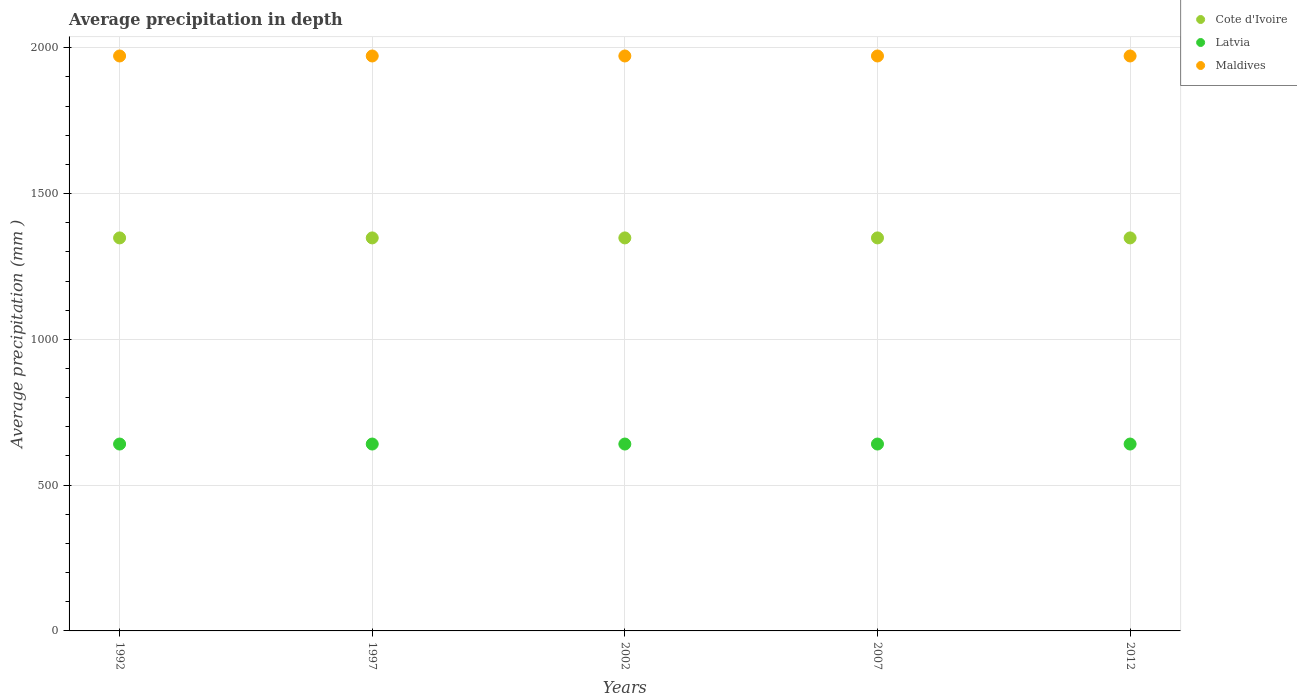How many different coloured dotlines are there?
Your answer should be very brief. 3. What is the average precipitation in Latvia in 2012?
Offer a terse response. 641. Across all years, what is the maximum average precipitation in Cote d'Ivoire?
Make the answer very short. 1348. In which year was the average precipitation in Maldives maximum?
Offer a very short reply. 1992. In which year was the average precipitation in Maldives minimum?
Keep it short and to the point. 1992. What is the total average precipitation in Maldives in the graph?
Provide a succinct answer. 9860. What is the difference between the average precipitation in Maldives in 1992 and that in 2007?
Ensure brevity in your answer.  0. What is the difference between the average precipitation in Latvia in 1997 and the average precipitation in Maldives in 2012?
Give a very brief answer. -1331. What is the average average precipitation in Maldives per year?
Give a very brief answer. 1972. In the year 2007, what is the difference between the average precipitation in Latvia and average precipitation in Maldives?
Offer a very short reply. -1331. Is the average precipitation in Latvia in 2007 less than that in 2012?
Offer a very short reply. No. Is the difference between the average precipitation in Latvia in 1997 and 2002 greater than the difference between the average precipitation in Maldives in 1997 and 2002?
Your answer should be very brief. No. What is the difference between the highest and the second highest average precipitation in Cote d'Ivoire?
Provide a short and direct response. 0. What is the difference between the highest and the lowest average precipitation in Cote d'Ivoire?
Provide a short and direct response. 0. Is it the case that in every year, the sum of the average precipitation in Latvia and average precipitation in Cote d'Ivoire  is greater than the average precipitation in Maldives?
Keep it short and to the point. Yes. How many years are there in the graph?
Your answer should be very brief. 5. Are the values on the major ticks of Y-axis written in scientific E-notation?
Your answer should be compact. No. Does the graph contain any zero values?
Offer a very short reply. No. Does the graph contain grids?
Your answer should be compact. Yes. How many legend labels are there?
Offer a very short reply. 3. How are the legend labels stacked?
Make the answer very short. Vertical. What is the title of the graph?
Ensure brevity in your answer.  Average precipitation in depth. What is the label or title of the X-axis?
Provide a succinct answer. Years. What is the label or title of the Y-axis?
Offer a very short reply. Average precipitation (mm ). What is the Average precipitation (mm ) in Cote d'Ivoire in 1992?
Provide a succinct answer. 1348. What is the Average precipitation (mm ) in Latvia in 1992?
Offer a terse response. 641. What is the Average precipitation (mm ) in Maldives in 1992?
Your answer should be compact. 1972. What is the Average precipitation (mm ) of Cote d'Ivoire in 1997?
Offer a very short reply. 1348. What is the Average precipitation (mm ) in Latvia in 1997?
Offer a terse response. 641. What is the Average precipitation (mm ) in Maldives in 1997?
Ensure brevity in your answer.  1972. What is the Average precipitation (mm ) of Cote d'Ivoire in 2002?
Ensure brevity in your answer.  1348. What is the Average precipitation (mm ) of Latvia in 2002?
Your answer should be very brief. 641. What is the Average precipitation (mm ) of Maldives in 2002?
Provide a succinct answer. 1972. What is the Average precipitation (mm ) in Cote d'Ivoire in 2007?
Offer a terse response. 1348. What is the Average precipitation (mm ) of Latvia in 2007?
Provide a succinct answer. 641. What is the Average precipitation (mm ) of Maldives in 2007?
Make the answer very short. 1972. What is the Average precipitation (mm ) in Cote d'Ivoire in 2012?
Your answer should be very brief. 1348. What is the Average precipitation (mm ) of Latvia in 2012?
Keep it short and to the point. 641. What is the Average precipitation (mm ) in Maldives in 2012?
Your answer should be very brief. 1972. Across all years, what is the maximum Average precipitation (mm ) in Cote d'Ivoire?
Your answer should be very brief. 1348. Across all years, what is the maximum Average precipitation (mm ) of Latvia?
Give a very brief answer. 641. Across all years, what is the maximum Average precipitation (mm ) of Maldives?
Ensure brevity in your answer.  1972. Across all years, what is the minimum Average precipitation (mm ) of Cote d'Ivoire?
Make the answer very short. 1348. Across all years, what is the minimum Average precipitation (mm ) of Latvia?
Your answer should be compact. 641. Across all years, what is the minimum Average precipitation (mm ) of Maldives?
Keep it short and to the point. 1972. What is the total Average precipitation (mm ) of Cote d'Ivoire in the graph?
Your answer should be very brief. 6740. What is the total Average precipitation (mm ) in Latvia in the graph?
Give a very brief answer. 3205. What is the total Average precipitation (mm ) in Maldives in the graph?
Make the answer very short. 9860. What is the difference between the Average precipitation (mm ) in Cote d'Ivoire in 1992 and that in 1997?
Your answer should be compact. 0. What is the difference between the Average precipitation (mm ) in Latvia in 1992 and that in 1997?
Your response must be concise. 0. What is the difference between the Average precipitation (mm ) in Cote d'Ivoire in 1992 and that in 2002?
Offer a very short reply. 0. What is the difference between the Average precipitation (mm ) in Latvia in 1992 and that in 2002?
Keep it short and to the point. 0. What is the difference between the Average precipitation (mm ) in Latvia in 1992 and that in 2007?
Make the answer very short. 0. What is the difference between the Average precipitation (mm ) of Cote d'Ivoire in 1997 and that in 2002?
Provide a succinct answer. 0. What is the difference between the Average precipitation (mm ) in Latvia in 1997 and that in 2002?
Provide a short and direct response. 0. What is the difference between the Average precipitation (mm ) in Maldives in 1997 and that in 2002?
Make the answer very short. 0. What is the difference between the Average precipitation (mm ) in Cote d'Ivoire in 1997 and that in 2007?
Give a very brief answer. 0. What is the difference between the Average precipitation (mm ) in Latvia in 1997 and that in 2012?
Give a very brief answer. 0. What is the difference between the Average precipitation (mm ) of Maldives in 2002 and that in 2007?
Your answer should be very brief. 0. What is the difference between the Average precipitation (mm ) of Maldives in 2002 and that in 2012?
Your response must be concise. 0. What is the difference between the Average precipitation (mm ) of Maldives in 2007 and that in 2012?
Make the answer very short. 0. What is the difference between the Average precipitation (mm ) in Cote d'Ivoire in 1992 and the Average precipitation (mm ) in Latvia in 1997?
Ensure brevity in your answer.  707. What is the difference between the Average precipitation (mm ) in Cote d'Ivoire in 1992 and the Average precipitation (mm ) in Maldives in 1997?
Your answer should be compact. -624. What is the difference between the Average precipitation (mm ) in Latvia in 1992 and the Average precipitation (mm ) in Maldives in 1997?
Keep it short and to the point. -1331. What is the difference between the Average precipitation (mm ) in Cote d'Ivoire in 1992 and the Average precipitation (mm ) in Latvia in 2002?
Your answer should be very brief. 707. What is the difference between the Average precipitation (mm ) in Cote d'Ivoire in 1992 and the Average precipitation (mm ) in Maldives in 2002?
Your answer should be compact. -624. What is the difference between the Average precipitation (mm ) in Latvia in 1992 and the Average precipitation (mm ) in Maldives in 2002?
Offer a very short reply. -1331. What is the difference between the Average precipitation (mm ) of Cote d'Ivoire in 1992 and the Average precipitation (mm ) of Latvia in 2007?
Give a very brief answer. 707. What is the difference between the Average precipitation (mm ) of Cote d'Ivoire in 1992 and the Average precipitation (mm ) of Maldives in 2007?
Ensure brevity in your answer.  -624. What is the difference between the Average precipitation (mm ) of Latvia in 1992 and the Average precipitation (mm ) of Maldives in 2007?
Make the answer very short. -1331. What is the difference between the Average precipitation (mm ) in Cote d'Ivoire in 1992 and the Average precipitation (mm ) in Latvia in 2012?
Ensure brevity in your answer.  707. What is the difference between the Average precipitation (mm ) in Cote d'Ivoire in 1992 and the Average precipitation (mm ) in Maldives in 2012?
Your response must be concise. -624. What is the difference between the Average precipitation (mm ) in Latvia in 1992 and the Average precipitation (mm ) in Maldives in 2012?
Your response must be concise. -1331. What is the difference between the Average precipitation (mm ) of Cote d'Ivoire in 1997 and the Average precipitation (mm ) of Latvia in 2002?
Your response must be concise. 707. What is the difference between the Average precipitation (mm ) in Cote d'Ivoire in 1997 and the Average precipitation (mm ) in Maldives in 2002?
Offer a terse response. -624. What is the difference between the Average precipitation (mm ) in Latvia in 1997 and the Average precipitation (mm ) in Maldives in 2002?
Offer a terse response. -1331. What is the difference between the Average precipitation (mm ) in Cote d'Ivoire in 1997 and the Average precipitation (mm ) in Latvia in 2007?
Offer a terse response. 707. What is the difference between the Average precipitation (mm ) in Cote d'Ivoire in 1997 and the Average precipitation (mm ) in Maldives in 2007?
Give a very brief answer. -624. What is the difference between the Average precipitation (mm ) of Latvia in 1997 and the Average precipitation (mm ) of Maldives in 2007?
Provide a short and direct response. -1331. What is the difference between the Average precipitation (mm ) in Cote d'Ivoire in 1997 and the Average precipitation (mm ) in Latvia in 2012?
Offer a terse response. 707. What is the difference between the Average precipitation (mm ) in Cote d'Ivoire in 1997 and the Average precipitation (mm ) in Maldives in 2012?
Offer a terse response. -624. What is the difference between the Average precipitation (mm ) of Latvia in 1997 and the Average precipitation (mm ) of Maldives in 2012?
Give a very brief answer. -1331. What is the difference between the Average precipitation (mm ) of Cote d'Ivoire in 2002 and the Average precipitation (mm ) of Latvia in 2007?
Make the answer very short. 707. What is the difference between the Average precipitation (mm ) in Cote d'Ivoire in 2002 and the Average precipitation (mm ) in Maldives in 2007?
Offer a terse response. -624. What is the difference between the Average precipitation (mm ) in Latvia in 2002 and the Average precipitation (mm ) in Maldives in 2007?
Provide a short and direct response. -1331. What is the difference between the Average precipitation (mm ) of Cote d'Ivoire in 2002 and the Average precipitation (mm ) of Latvia in 2012?
Make the answer very short. 707. What is the difference between the Average precipitation (mm ) of Cote d'Ivoire in 2002 and the Average precipitation (mm ) of Maldives in 2012?
Your response must be concise. -624. What is the difference between the Average precipitation (mm ) in Latvia in 2002 and the Average precipitation (mm ) in Maldives in 2012?
Give a very brief answer. -1331. What is the difference between the Average precipitation (mm ) in Cote d'Ivoire in 2007 and the Average precipitation (mm ) in Latvia in 2012?
Provide a short and direct response. 707. What is the difference between the Average precipitation (mm ) in Cote d'Ivoire in 2007 and the Average precipitation (mm ) in Maldives in 2012?
Provide a short and direct response. -624. What is the difference between the Average precipitation (mm ) of Latvia in 2007 and the Average precipitation (mm ) of Maldives in 2012?
Provide a short and direct response. -1331. What is the average Average precipitation (mm ) of Cote d'Ivoire per year?
Give a very brief answer. 1348. What is the average Average precipitation (mm ) in Latvia per year?
Ensure brevity in your answer.  641. What is the average Average precipitation (mm ) in Maldives per year?
Give a very brief answer. 1972. In the year 1992, what is the difference between the Average precipitation (mm ) in Cote d'Ivoire and Average precipitation (mm ) in Latvia?
Your response must be concise. 707. In the year 1992, what is the difference between the Average precipitation (mm ) of Cote d'Ivoire and Average precipitation (mm ) of Maldives?
Offer a very short reply. -624. In the year 1992, what is the difference between the Average precipitation (mm ) of Latvia and Average precipitation (mm ) of Maldives?
Ensure brevity in your answer.  -1331. In the year 1997, what is the difference between the Average precipitation (mm ) in Cote d'Ivoire and Average precipitation (mm ) in Latvia?
Make the answer very short. 707. In the year 1997, what is the difference between the Average precipitation (mm ) in Cote d'Ivoire and Average precipitation (mm ) in Maldives?
Provide a short and direct response. -624. In the year 1997, what is the difference between the Average precipitation (mm ) of Latvia and Average precipitation (mm ) of Maldives?
Your answer should be very brief. -1331. In the year 2002, what is the difference between the Average precipitation (mm ) of Cote d'Ivoire and Average precipitation (mm ) of Latvia?
Provide a succinct answer. 707. In the year 2002, what is the difference between the Average precipitation (mm ) in Cote d'Ivoire and Average precipitation (mm ) in Maldives?
Make the answer very short. -624. In the year 2002, what is the difference between the Average precipitation (mm ) in Latvia and Average precipitation (mm ) in Maldives?
Offer a very short reply. -1331. In the year 2007, what is the difference between the Average precipitation (mm ) of Cote d'Ivoire and Average precipitation (mm ) of Latvia?
Provide a short and direct response. 707. In the year 2007, what is the difference between the Average precipitation (mm ) of Cote d'Ivoire and Average precipitation (mm ) of Maldives?
Provide a short and direct response. -624. In the year 2007, what is the difference between the Average precipitation (mm ) in Latvia and Average precipitation (mm ) in Maldives?
Your answer should be very brief. -1331. In the year 2012, what is the difference between the Average precipitation (mm ) of Cote d'Ivoire and Average precipitation (mm ) of Latvia?
Provide a short and direct response. 707. In the year 2012, what is the difference between the Average precipitation (mm ) in Cote d'Ivoire and Average precipitation (mm ) in Maldives?
Ensure brevity in your answer.  -624. In the year 2012, what is the difference between the Average precipitation (mm ) of Latvia and Average precipitation (mm ) of Maldives?
Make the answer very short. -1331. What is the ratio of the Average precipitation (mm ) of Latvia in 1992 to that in 1997?
Your answer should be compact. 1. What is the ratio of the Average precipitation (mm ) of Maldives in 1992 to that in 2007?
Your response must be concise. 1. What is the ratio of the Average precipitation (mm ) of Cote d'Ivoire in 1992 to that in 2012?
Keep it short and to the point. 1. What is the ratio of the Average precipitation (mm ) in Latvia in 1992 to that in 2012?
Ensure brevity in your answer.  1. What is the ratio of the Average precipitation (mm ) in Maldives in 1992 to that in 2012?
Your response must be concise. 1. What is the ratio of the Average precipitation (mm ) of Latvia in 1997 to that in 2002?
Provide a succinct answer. 1. What is the ratio of the Average precipitation (mm ) of Cote d'Ivoire in 1997 to that in 2007?
Your answer should be very brief. 1. What is the ratio of the Average precipitation (mm ) in Cote d'Ivoire in 2002 to that in 2007?
Provide a short and direct response. 1. What is the ratio of the Average precipitation (mm ) in Cote d'Ivoire in 2002 to that in 2012?
Give a very brief answer. 1. What is the ratio of the Average precipitation (mm ) in Latvia in 2002 to that in 2012?
Offer a very short reply. 1. What is the ratio of the Average precipitation (mm ) in Latvia in 2007 to that in 2012?
Provide a short and direct response. 1. What is the difference between the highest and the second highest Average precipitation (mm ) of Latvia?
Your answer should be compact. 0. What is the difference between the highest and the lowest Average precipitation (mm ) of Cote d'Ivoire?
Keep it short and to the point. 0. What is the difference between the highest and the lowest Average precipitation (mm ) of Latvia?
Your response must be concise. 0. 